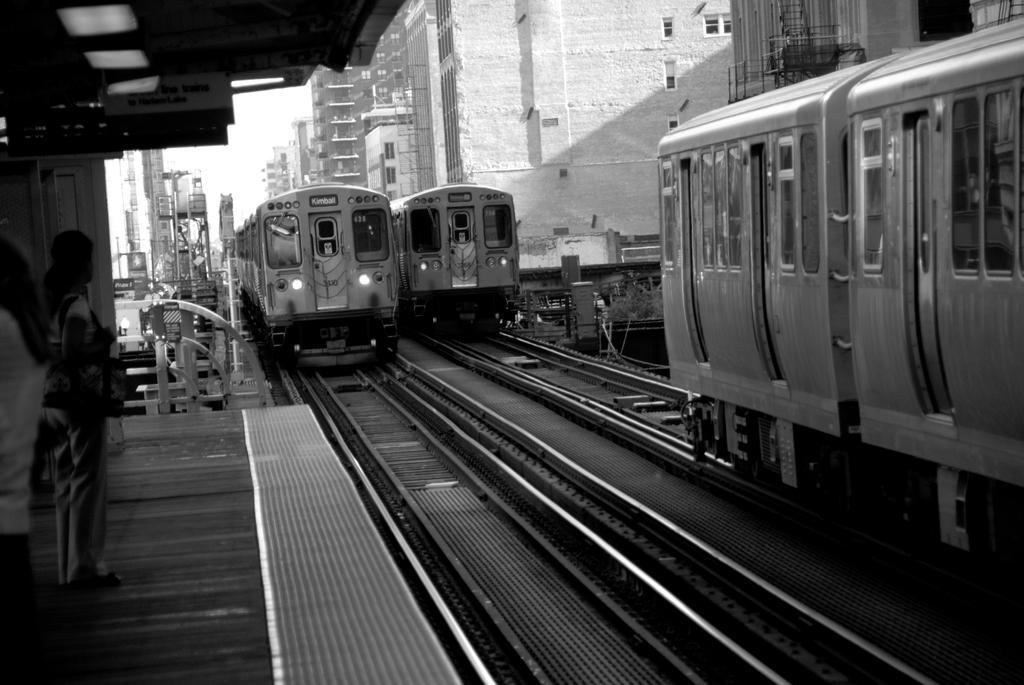Could you give a brief overview of what you see in this image? In this image on the left side there are persons standing. In the center there are trains running on the railway track. On the right side there are buildings and in the background there are poles and buildings. 